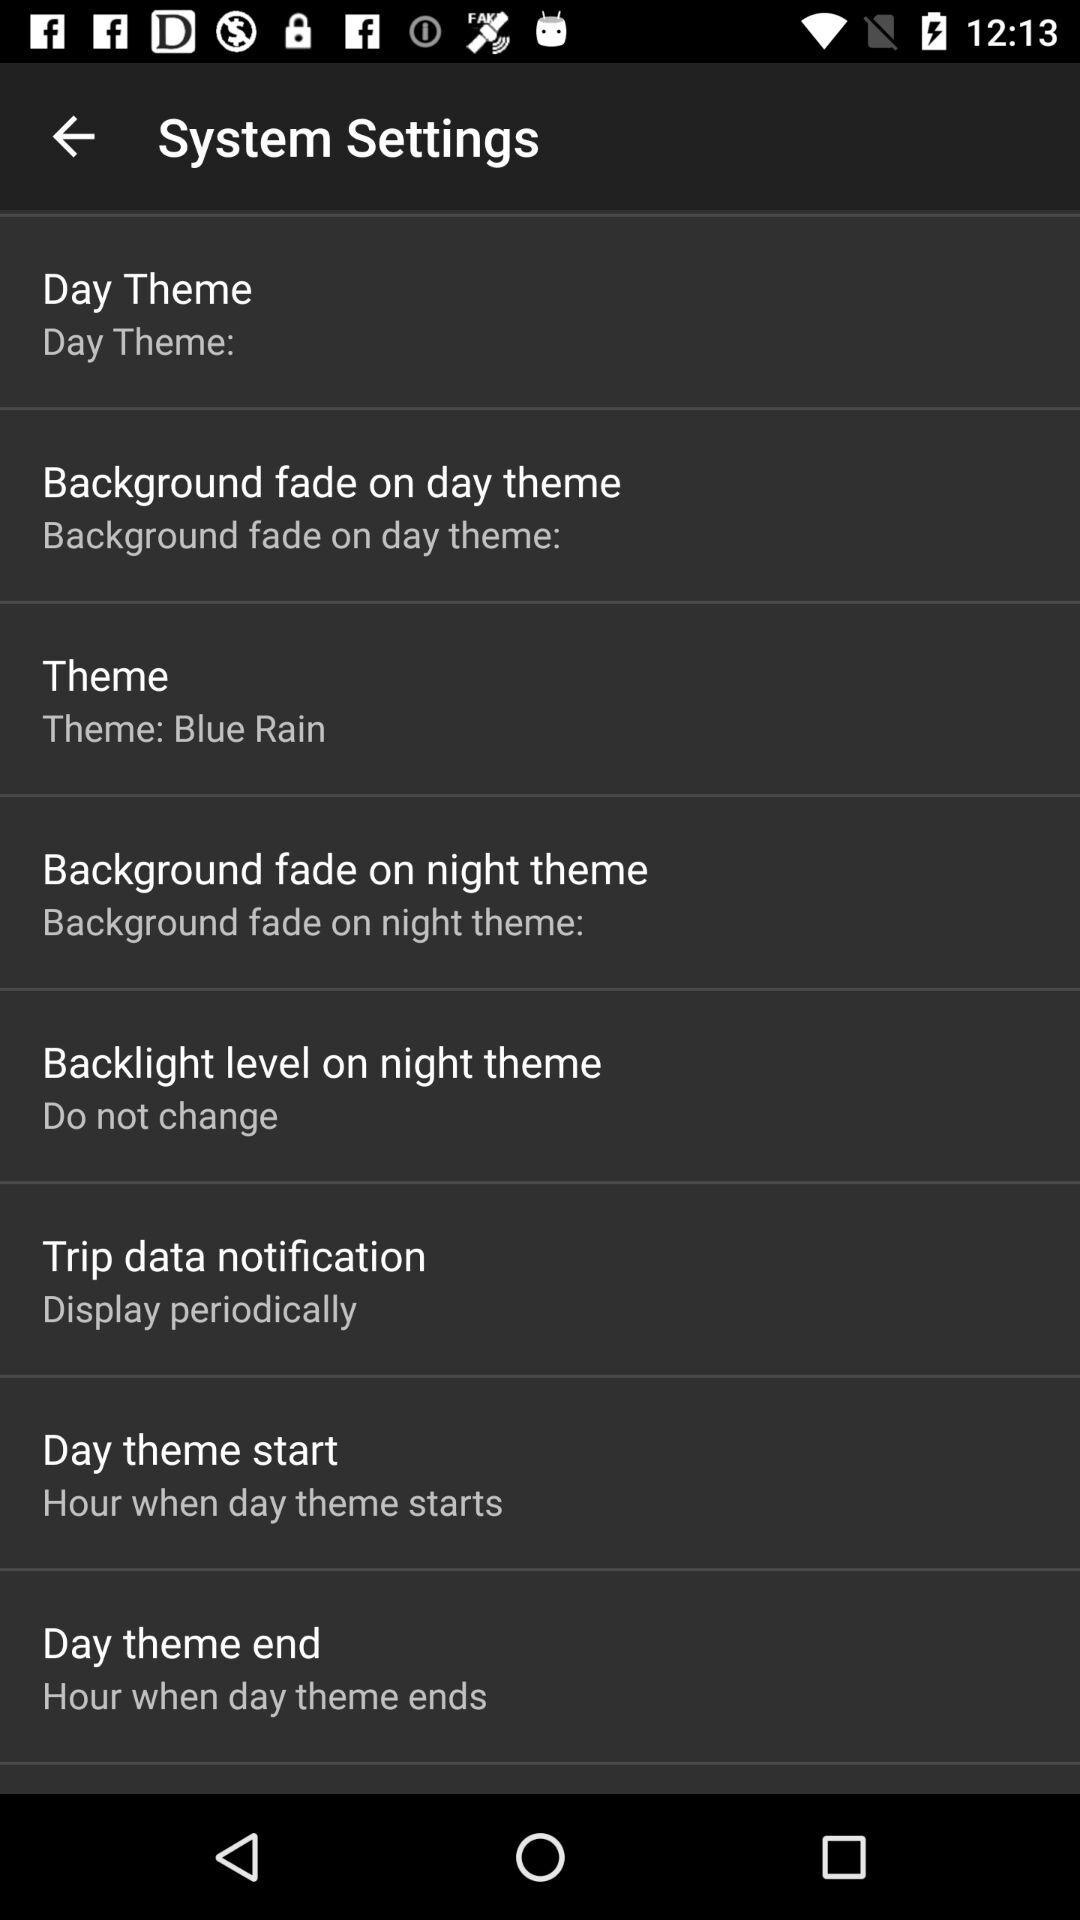What is the theme? The theme is "Blue Rain". 